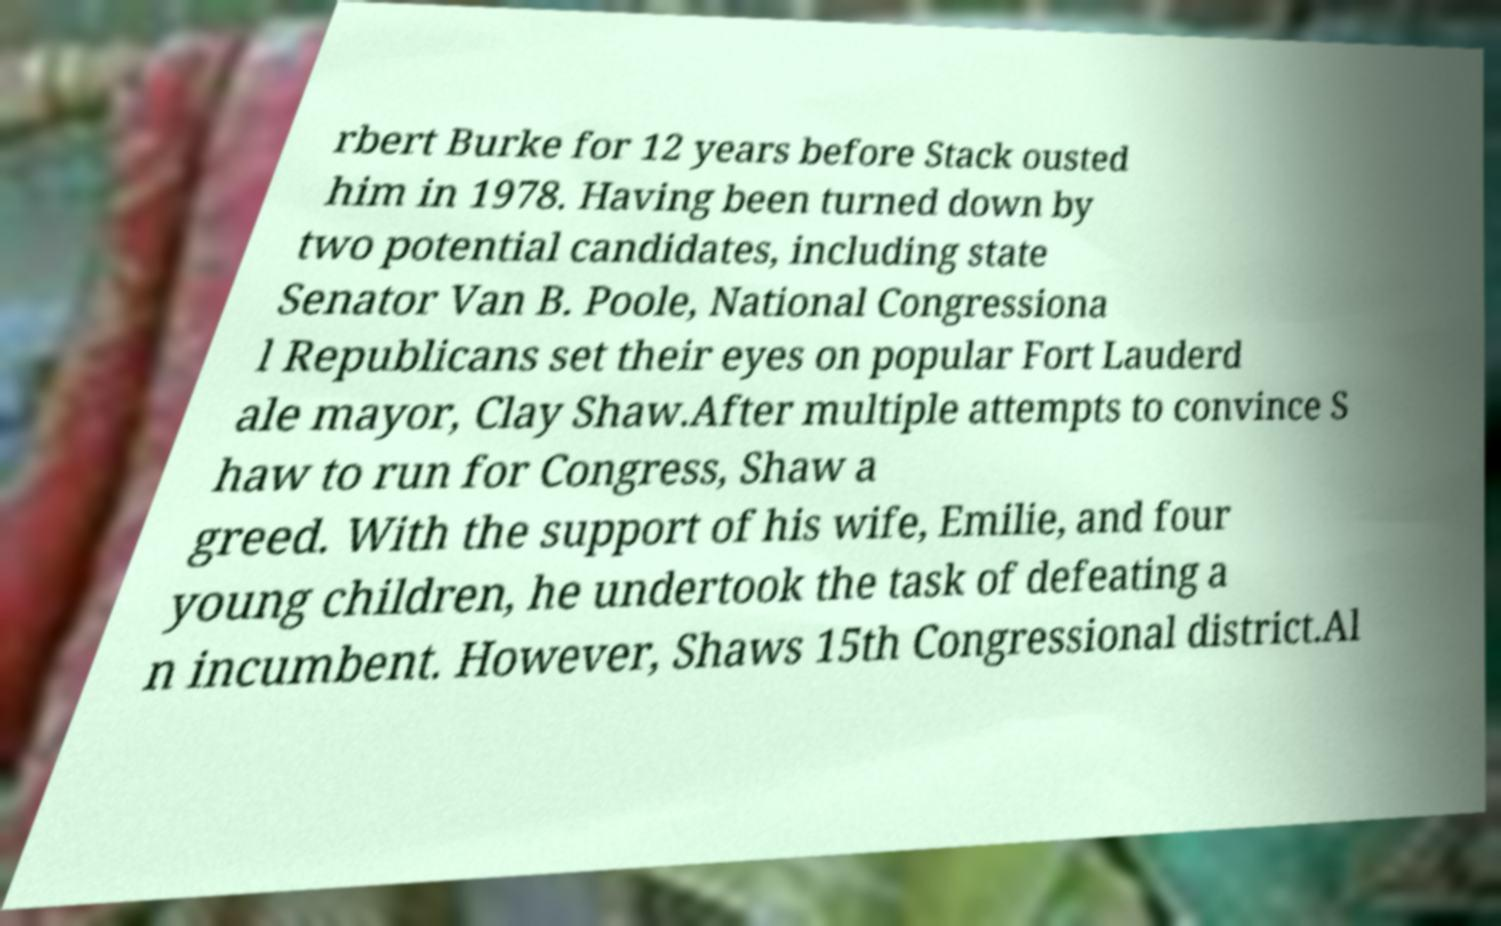For documentation purposes, I need the text within this image transcribed. Could you provide that? rbert Burke for 12 years before Stack ousted him in 1978. Having been turned down by two potential candidates, including state Senator Van B. Poole, National Congressiona l Republicans set their eyes on popular Fort Lauderd ale mayor, Clay Shaw.After multiple attempts to convince S haw to run for Congress, Shaw a greed. With the support of his wife, Emilie, and four young children, he undertook the task of defeating a n incumbent. However, Shaws 15th Congressional district.Al 